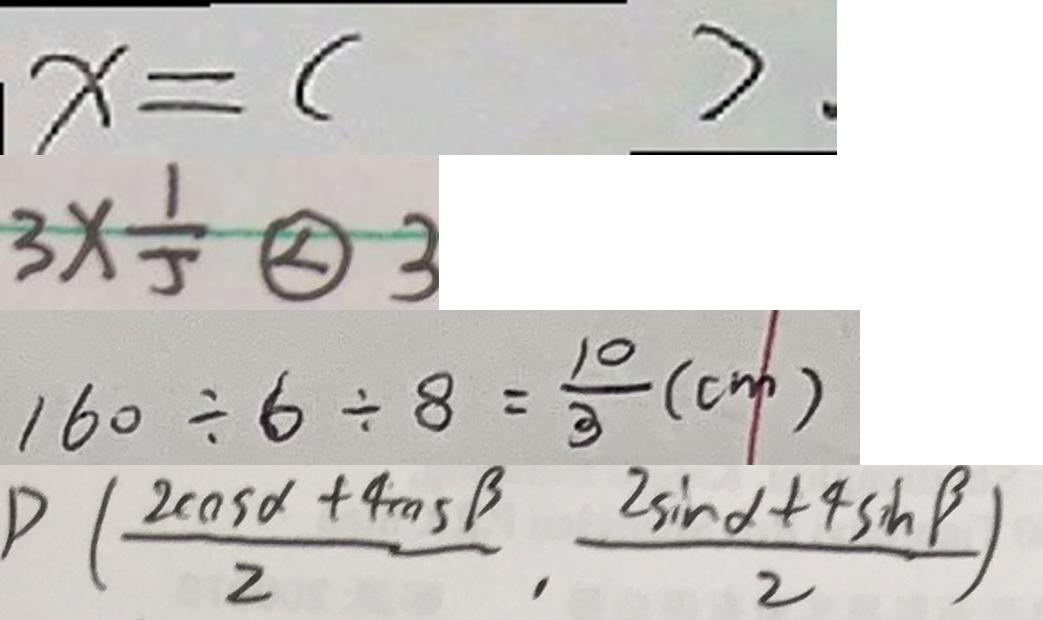<formula> <loc_0><loc_0><loc_500><loc_500>x = ( ) . 
 3 \times \frac { 1 } { 5 } \textcircled { < } 3 
 1 6 0 \div 6 \div 8 = \frac { 1 0 } { 3 } ( c m ) 
 P ( \frac { 2 \cos \alpha + 4 \cos \beta } { 2 } , \frac { 2 \sin \alpha + 4 \sin \beta } { 2 } )</formula> 